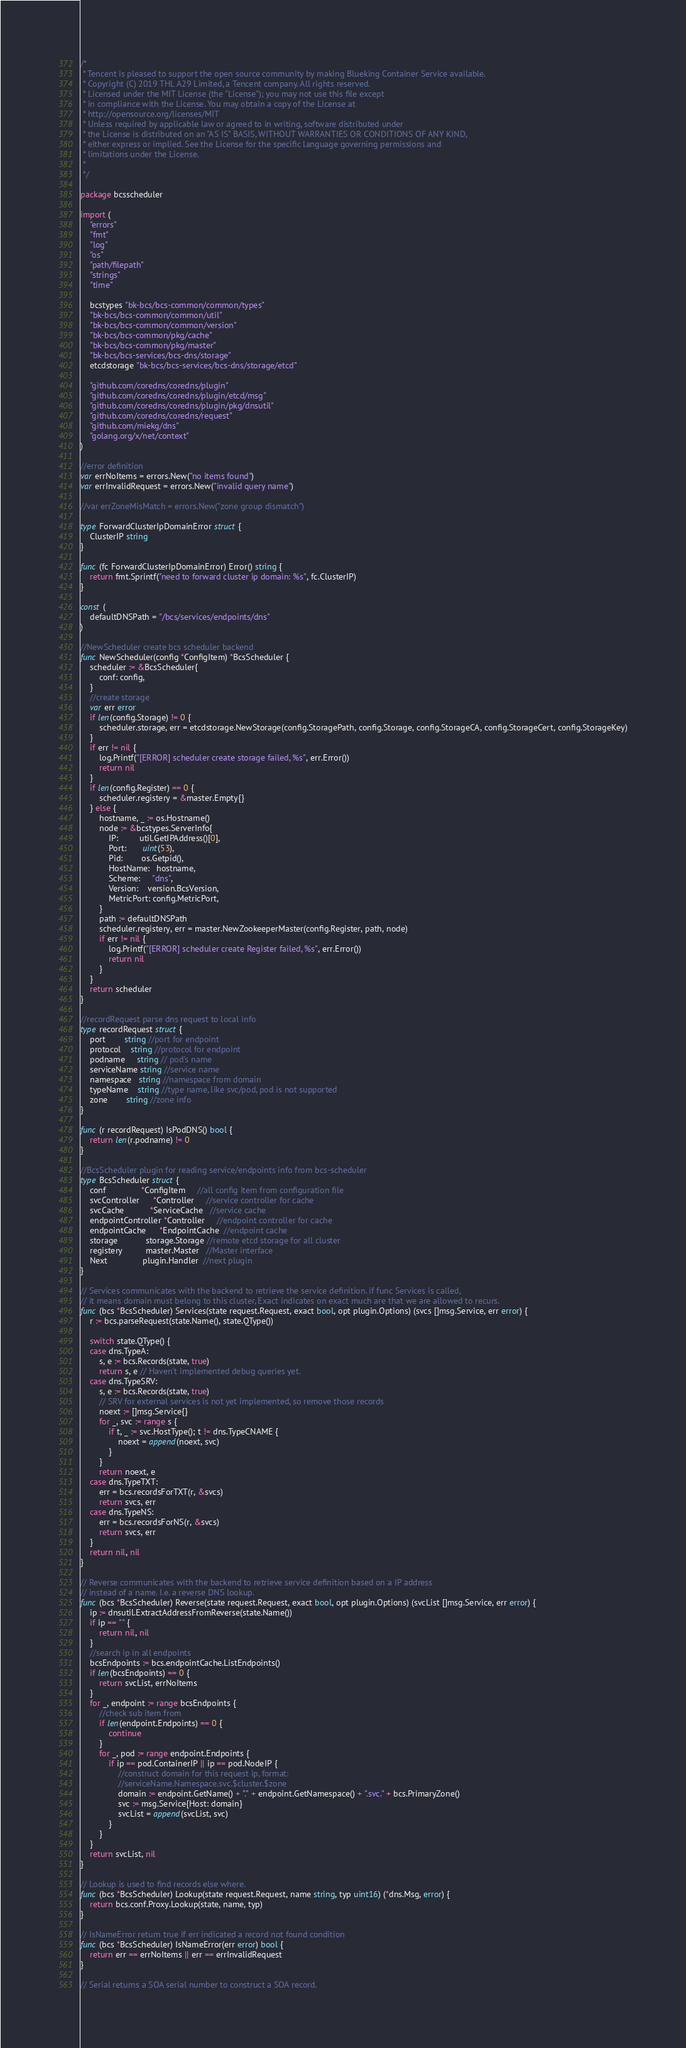<code> <loc_0><loc_0><loc_500><loc_500><_Go_>/*
 * Tencent is pleased to support the open source community by making Blueking Container Service available.
 * Copyright (C) 2019 THL A29 Limited, a Tencent company. All rights reserved.
 * Licensed under the MIT License (the "License"); you may not use this file except
 * in compliance with the License. You may obtain a copy of the License at
 * http://opensource.org/licenses/MIT
 * Unless required by applicable law or agreed to in writing, software distributed under
 * the License is distributed on an "AS IS" BASIS, WITHOUT WARRANTIES OR CONDITIONS OF ANY KIND,
 * either express or implied. See the License for the specific language governing permissions and
 * limitations under the License.
 *
 */

package bcsscheduler

import (
	"errors"
	"fmt"
	"log"
	"os"
	"path/filepath"
	"strings"
	"time"

	bcstypes "bk-bcs/bcs-common/common/types"
	"bk-bcs/bcs-common/common/util"
	"bk-bcs/bcs-common/common/version"
	"bk-bcs/bcs-common/pkg/cache"
	"bk-bcs/bcs-common/pkg/master"
	"bk-bcs/bcs-services/bcs-dns/storage"
	etcdstorage "bk-bcs/bcs-services/bcs-dns/storage/etcd"

	"github.com/coredns/coredns/plugin"
	"github.com/coredns/coredns/plugin/etcd/msg"
	"github.com/coredns/coredns/plugin/pkg/dnsutil"
	"github.com/coredns/coredns/request"
	"github.com/miekg/dns"
	"golang.org/x/net/context"
)

//error definition
var errNoItems = errors.New("no items found")
var errInvalidRequest = errors.New("invalid query name")

//var errZoneMisMatch = errors.New("zone group dismatch")

type ForwardClusterIpDomainError struct {
	ClusterIP string
}

func (fc ForwardClusterIpDomainError) Error() string {
	return fmt.Sprintf("need to forward cluster ip domain: %s", fc.ClusterIP)
}

const (
	defaultDNSPath = "/bcs/services/endpoints/dns"
)

//NewScheduler create bcs scheduler backend
func NewScheduler(config *ConfigItem) *BcsScheduler {
	scheduler := &BcsScheduler{
		conf: config,
	}
	//create storage
	var err error
	if len(config.Storage) != 0 {
		scheduler.storage, err = etcdstorage.NewStorage(config.StoragePath, config.Storage, config.StorageCA, config.StorageCert, config.StorageKey)
	}
	if err != nil {
		log.Printf("[ERROR] scheduler create storage failed, %s", err.Error())
		return nil
	}
	if len(config.Register) == 0 {
		scheduler.registery = &master.Empty{}
	} else {
		hostname, _ := os.Hostname()
		node := &bcstypes.ServerInfo{
			IP:         util.GetIPAddress()[0],
			Port:       uint(53),
			Pid:        os.Getpid(),
			HostName:   hostname,
			Scheme:     "dns",
			Version:    version.BcsVersion,
			MetricPort: config.MetricPort,
		}
		path := defaultDNSPath
		scheduler.registery, err = master.NewZookeeperMaster(config.Register, path, node)
		if err != nil {
			log.Printf("[ERROR] scheduler create Register failed, %s", err.Error())
			return nil
		}
	}
	return scheduler
}

//recordRequest parse dns request to local info
type recordRequest struct {
	port        string //port for endpoint
	protocol    string //protocol for endpoint
	podname     string // pod's name
	serviceName string //service name
	namespace   string //namespace from domain
	typeName    string //type name, like svc/pod, pod is not supported
	zone        string //zone info
}

func (r recordRequest) IsPodDNS() bool {
	return len(r.podname) != 0
}

//BcsScheduler plugin for reading service/endpoints info from bcs-scheduler
type BcsScheduler struct {
	conf               *ConfigItem     //all config item from configuration file
	svcController      *Controller     //service controller for cache
	svcCache           *ServiceCache   //service cache
	endpointController *Controller     //endpoint controller for cache
	endpointCache      *EndpointCache  //endpoint cache
	storage            storage.Storage //remote etcd storage for all cluster
	registery          master.Master   //Master interface
	Next               plugin.Handler  //next plugin
}

// Services communicates with the backend to retrieve the service definition. if func Services is called,
// it means domain must belong to this cluster, Exact indicates on exact much are that we are allowed to recurs.
func (bcs *BcsScheduler) Services(state request.Request, exact bool, opt plugin.Options) (svcs []msg.Service, err error) {
	r := bcs.parseRequest(state.Name(), state.QType())

	switch state.QType() {
	case dns.TypeA:
		s, e := bcs.Records(state, true)
		return s, e // Haven't implemented debug queries yet.
	case dns.TypeSRV:
		s, e := bcs.Records(state, true)
		// SRV for external services is not yet implemented, so remove those records
		noext := []msg.Service{}
		for _, svc := range s {
			if t, _ := svc.HostType(); t != dns.TypeCNAME {
				noext = append(noext, svc)
			}
		}
		return noext, e
	case dns.TypeTXT:
		err = bcs.recordsForTXT(r, &svcs)
		return svcs, err
	case dns.TypeNS:
		err = bcs.recordsForNS(r, &svcs)
		return svcs, err
	}
	return nil, nil
}

// Reverse communicates with the backend to retrieve service definition based on a IP address
// instead of a name. I.e. a reverse DNS lookup.
func (bcs *BcsScheduler) Reverse(state request.Request, exact bool, opt plugin.Options) (svcList []msg.Service, err error) {
	ip := dnsutil.ExtractAddressFromReverse(state.Name())
	if ip == "" {
		return nil, nil
	}
	//search ip in all endpoints
	bcsEndpoints := bcs.endpointCache.ListEndpoints()
	if len(bcsEndpoints) == 0 {
		return svcList, errNoItems
	}
	for _, endpoint := range bcsEndpoints {
		//check sub item from
		if len(endpoint.Endpoints) == 0 {
			continue
		}
		for _, pod := range endpoint.Endpoints {
			if ip == pod.ContainerIP || ip == pod.NodeIP {
				//construct domain for this request ip, format:
				//serviceName.Namespace.svc.$cluster.$zone
				domain := endpoint.GetName() + "." + endpoint.GetNamespace() + ".svc." + bcs.PrimaryZone()
				svc := msg.Service{Host: domain}
				svcList = append(svcList, svc)
			}
		}
	}
	return svcList, nil
}

// Lookup is used to find records else where.
func (bcs *BcsScheduler) Lookup(state request.Request, name string, typ uint16) (*dns.Msg, error) {
	return bcs.conf.Proxy.Lookup(state, name, typ)
}

// IsNameError return true if err indicated a record not found condition
func (bcs *BcsScheduler) IsNameError(err error) bool {
	return err == errNoItems || err == errInvalidRequest
}

// Serial returns a SOA serial number to construct a SOA record.</code> 